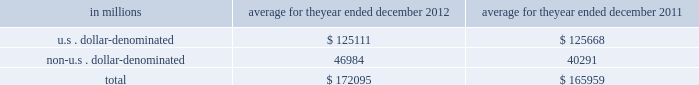Management 2019s discussion and analysis liquidity risk management liquidity is of critical importance to financial institutions .
Most of the recent failures of financial institutions have occurred in large part due to insufficient liquidity .
Accordingly , the firm has in place a comprehensive and conservative set of liquidity and funding policies to address both firm-specific and broader industry or market liquidity events .
Our principal objective is to be able to fund the firm and to enable our core businesses to continue to serve clients and generate revenues , even under adverse circumstances .
We manage liquidity risk according to the following principles : excess liquidity .
We maintain substantial excess liquidity to meet a broad range of potential cash outflows and collateral needs in a stressed environment .
Asset-liability management .
We assess anticipated holding periods for our assets and their expected liquidity in a stressed environment .
We manage the maturities and diversity of our funding across markets , products and counterparties , and seek to maintain liabilities of appropriate tenor relative to our asset base .
Contingency funding plan .
We maintain a contingency funding plan to provide a framework for analyzing and responding to a liquidity crisis situation or periods of market stress .
This framework sets forth the plan of action to fund normal business activity in emergency and stress situations .
These principles are discussed in more detail below .
Excess liquidity our most important liquidity policy is to pre-fund our estimated potential cash and collateral needs during a liquidity crisis and hold this excess liquidity in the form of unencumbered , highly liquid securities and cash .
We believe that the securities held in our global core excess would be readily convertible to cash in a matter of days , through liquidation , by entering into repurchase agreements or from maturities of reverse repurchase agreements , and that this cash would allow us to meet immediate obligations without needing to sell other assets or depend on additional funding from credit-sensitive markets .
As of december 2012 and december 2011 , the fair value of the securities and certain overnight cash deposits included in our gce totaled $ 174.62 billion and $ 171.58 billion , respectively .
Based on the results of our internal liquidity risk model , discussed below , as well as our consideration of other factors including , but not limited to , a qualitative assessment of the condition of the financial markets and the firm , we believe our liquidity position as of december 2012 was appropriate .
The table below presents the fair value of the securities and certain overnight cash deposits that are included in our gce .
Average for the year ended december in millions 2012 2011 .
The u.s .
Dollar-denominated excess is composed of ( i ) unencumbered u.s .
Government and federal agency obligations ( including highly liquid u.s .
Federal agency mortgage-backed obligations ) , all of which are eligible as collateral in federal reserve open market operations and ( ii ) certain overnight u.s .
Dollar cash deposits .
The non-u.s .
Dollar-denominated excess is composed of only unencumbered german , french , japanese and united kingdom government obligations and certain overnight cash deposits in highly liquid currencies .
We strictly limit our excess liquidity to this narrowly defined list of securities and cash because they are highly liquid , even in a difficult funding environment .
We do not include other potential sources of excess liquidity , such as less liquid unencumbered securities or committed credit facilities , in our gce .
Goldman sachs 2012 annual report 81 .
What percentage of gce in 2012 is in non-u.s . dollar-denominated assets? 
Computations: (46984 / 172095)
Answer: 0.27301. Management 2019s discussion and analysis liquidity risk management liquidity is of critical importance to financial institutions .
Most of the recent failures of financial institutions have occurred in large part due to insufficient liquidity .
Accordingly , the firm has in place a comprehensive and conservative set of liquidity and funding policies to address both firm-specific and broader industry or market liquidity events .
Our principal objective is to be able to fund the firm and to enable our core businesses to continue to serve clients and generate revenues , even under adverse circumstances .
We manage liquidity risk according to the following principles : excess liquidity .
We maintain substantial excess liquidity to meet a broad range of potential cash outflows and collateral needs in a stressed environment .
Asset-liability management .
We assess anticipated holding periods for our assets and their expected liquidity in a stressed environment .
We manage the maturities and diversity of our funding across markets , products and counterparties , and seek to maintain liabilities of appropriate tenor relative to our asset base .
Contingency funding plan .
We maintain a contingency funding plan to provide a framework for analyzing and responding to a liquidity crisis situation or periods of market stress .
This framework sets forth the plan of action to fund normal business activity in emergency and stress situations .
These principles are discussed in more detail below .
Excess liquidity our most important liquidity policy is to pre-fund our estimated potential cash and collateral needs during a liquidity crisis and hold this excess liquidity in the form of unencumbered , highly liquid securities and cash .
We believe that the securities held in our global core excess would be readily convertible to cash in a matter of days , through liquidation , by entering into repurchase agreements or from maturities of reverse repurchase agreements , and that this cash would allow us to meet immediate obligations without needing to sell other assets or depend on additional funding from credit-sensitive markets .
As of december 2012 and december 2011 , the fair value of the securities and certain overnight cash deposits included in our gce totaled $ 174.62 billion and $ 171.58 billion , respectively .
Based on the results of our internal liquidity risk model , discussed below , as well as our consideration of other factors including , but not limited to , a qualitative assessment of the condition of the financial markets and the firm , we believe our liquidity position as of december 2012 was appropriate .
The table below presents the fair value of the securities and certain overnight cash deposits that are included in our gce .
Average for the year ended december in millions 2012 2011 .
The u.s .
Dollar-denominated excess is composed of ( i ) unencumbered u.s .
Government and federal agency obligations ( including highly liquid u.s .
Federal agency mortgage-backed obligations ) , all of which are eligible as collateral in federal reserve open market operations and ( ii ) certain overnight u.s .
Dollar cash deposits .
The non-u.s .
Dollar-denominated excess is composed of only unencumbered german , french , japanese and united kingdom government obligations and certain overnight cash deposits in highly liquid currencies .
We strictly limit our excess liquidity to this narrowly defined list of securities and cash because they are highly liquid , even in a difficult funding environment .
We do not include other potential sources of excess liquidity , such as less liquid unencumbered securities or committed credit facilities , in our gce .
Goldman sachs 2012 annual report 81 .
What percentage of gce in 2011 is in non-u.s . dollar-denominated assets? 
Computations: (40291 / 165959)
Answer: 0.24278. Management 2019s discussion and analysis liquidity risk management liquidity is of critical importance to financial institutions .
Most of the recent failures of financial institutions have occurred in large part due to insufficient liquidity .
Accordingly , the firm has in place a comprehensive and conservative set of liquidity and funding policies to address both firm-specific and broader industry or market liquidity events .
Our principal objective is to be able to fund the firm and to enable our core businesses to continue to serve clients and generate revenues , even under adverse circumstances .
We manage liquidity risk according to the following principles : excess liquidity .
We maintain substantial excess liquidity to meet a broad range of potential cash outflows and collateral needs in a stressed environment .
Asset-liability management .
We assess anticipated holding periods for our assets and their expected liquidity in a stressed environment .
We manage the maturities and diversity of our funding across markets , products and counterparties , and seek to maintain liabilities of appropriate tenor relative to our asset base .
Contingency funding plan .
We maintain a contingency funding plan to provide a framework for analyzing and responding to a liquidity crisis situation or periods of market stress .
This framework sets forth the plan of action to fund normal business activity in emergency and stress situations .
These principles are discussed in more detail below .
Excess liquidity our most important liquidity policy is to pre-fund our estimated potential cash and collateral needs during a liquidity crisis and hold this excess liquidity in the form of unencumbered , highly liquid securities and cash .
We believe that the securities held in our global core excess would be readily convertible to cash in a matter of days , through liquidation , by entering into repurchase agreements or from maturities of reverse repurchase agreements , and that this cash would allow us to meet immediate obligations without needing to sell other assets or depend on additional funding from credit-sensitive markets .
As of december 2012 and december 2011 , the fair value of the securities and certain overnight cash deposits included in our gce totaled $ 174.62 billion and $ 171.58 billion , respectively .
Based on the results of our internal liquidity risk model , discussed below , as well as our consideration of other factors including , but not limited to , a qualitative assessment of the condition of the financial markets and the firm , we believe our liquidity position as of december 2012 was appropriate .
The table below presents the fair value of the securities and certain overnight cash deposits that are included in our gce .
Average for the year ended december in millions 2012 2011 .
The u.s .
Dollar-denominated excess is composed of ( i ) unencumbered u.s .
Government and federal agency obligations ( including highly liquid u.s .
Federal agency mortgage-backed obligations ) , all of which are eligible as collateral in federal reserve open market operations and ( ii ) certain overnight u.s .
Dollar cash deposits .
The non-u.s .
Dollar-denominated excess is composed of only unencumbered german , french , japanese and united kingdom government obligations and certain overnight cash deposits in highly liquid currencies .
We strictly limit our excess liquidity to this narrowly defined list of securities and cash because they are highly liquid , even in a difficult funding environment .
We do not include other potential sources of excess liquidity , such as less liquid unencumbered securities or committed credit facilities , in our gce .
Goldman sachs 2012 annual report 81 .
What was the change as of december 2012 and december 2011 in the fair value of the securities and certain overnight cash deposits in billions? 
Computations: (174.62 - 171.58)
Answer: 3.04. 